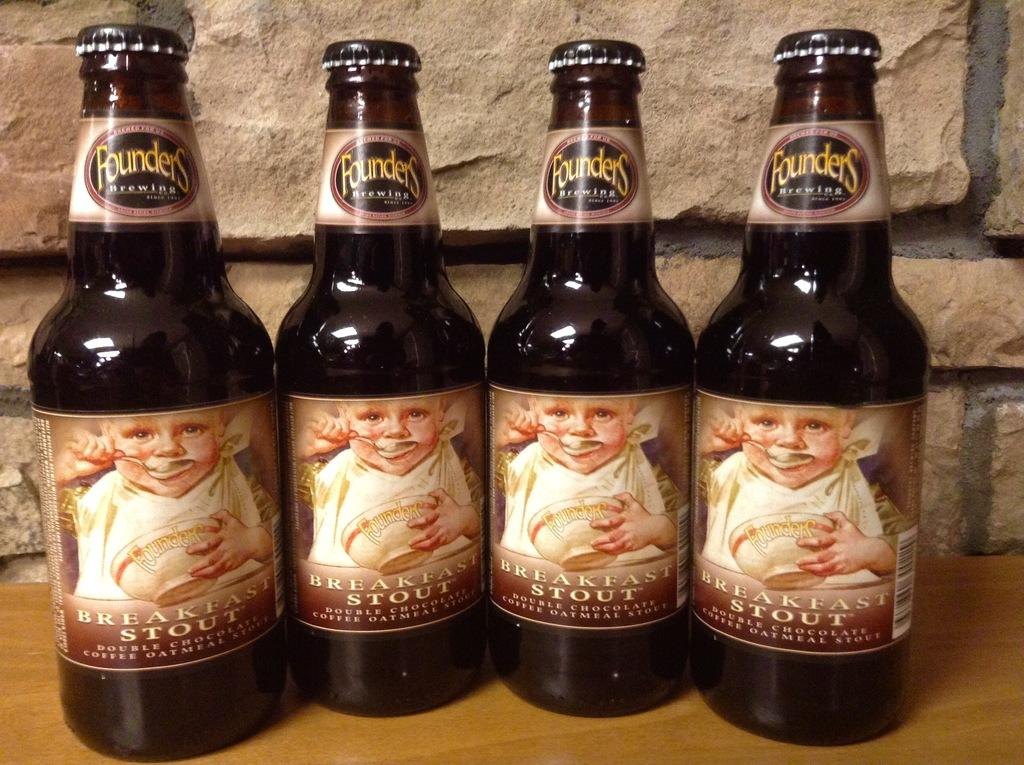<image>
Create a compact narrative representing the image presented. Four bottles of Breakfast Stout by Founders Brewing are sitting next to each other. 